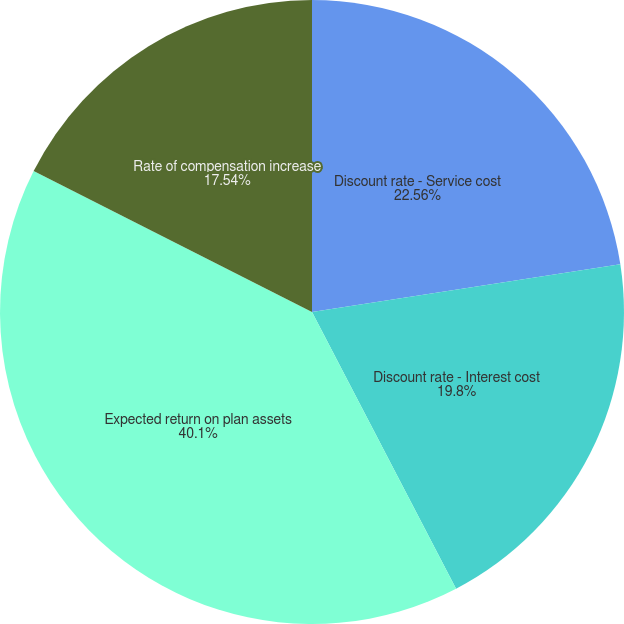<chart> <loc_0><loc_0><loc_500><loc_500><pie_chart><fcel>Discount rate - Service cost<fcel>Discount rate - Interest cost<fcel>Expected return on plan assets<fcel>Rate of compensation increase<nl><fcel>22.56%<fcel>19.8%<fcel>40.1%<fcel>17.54%<nl></chart> 